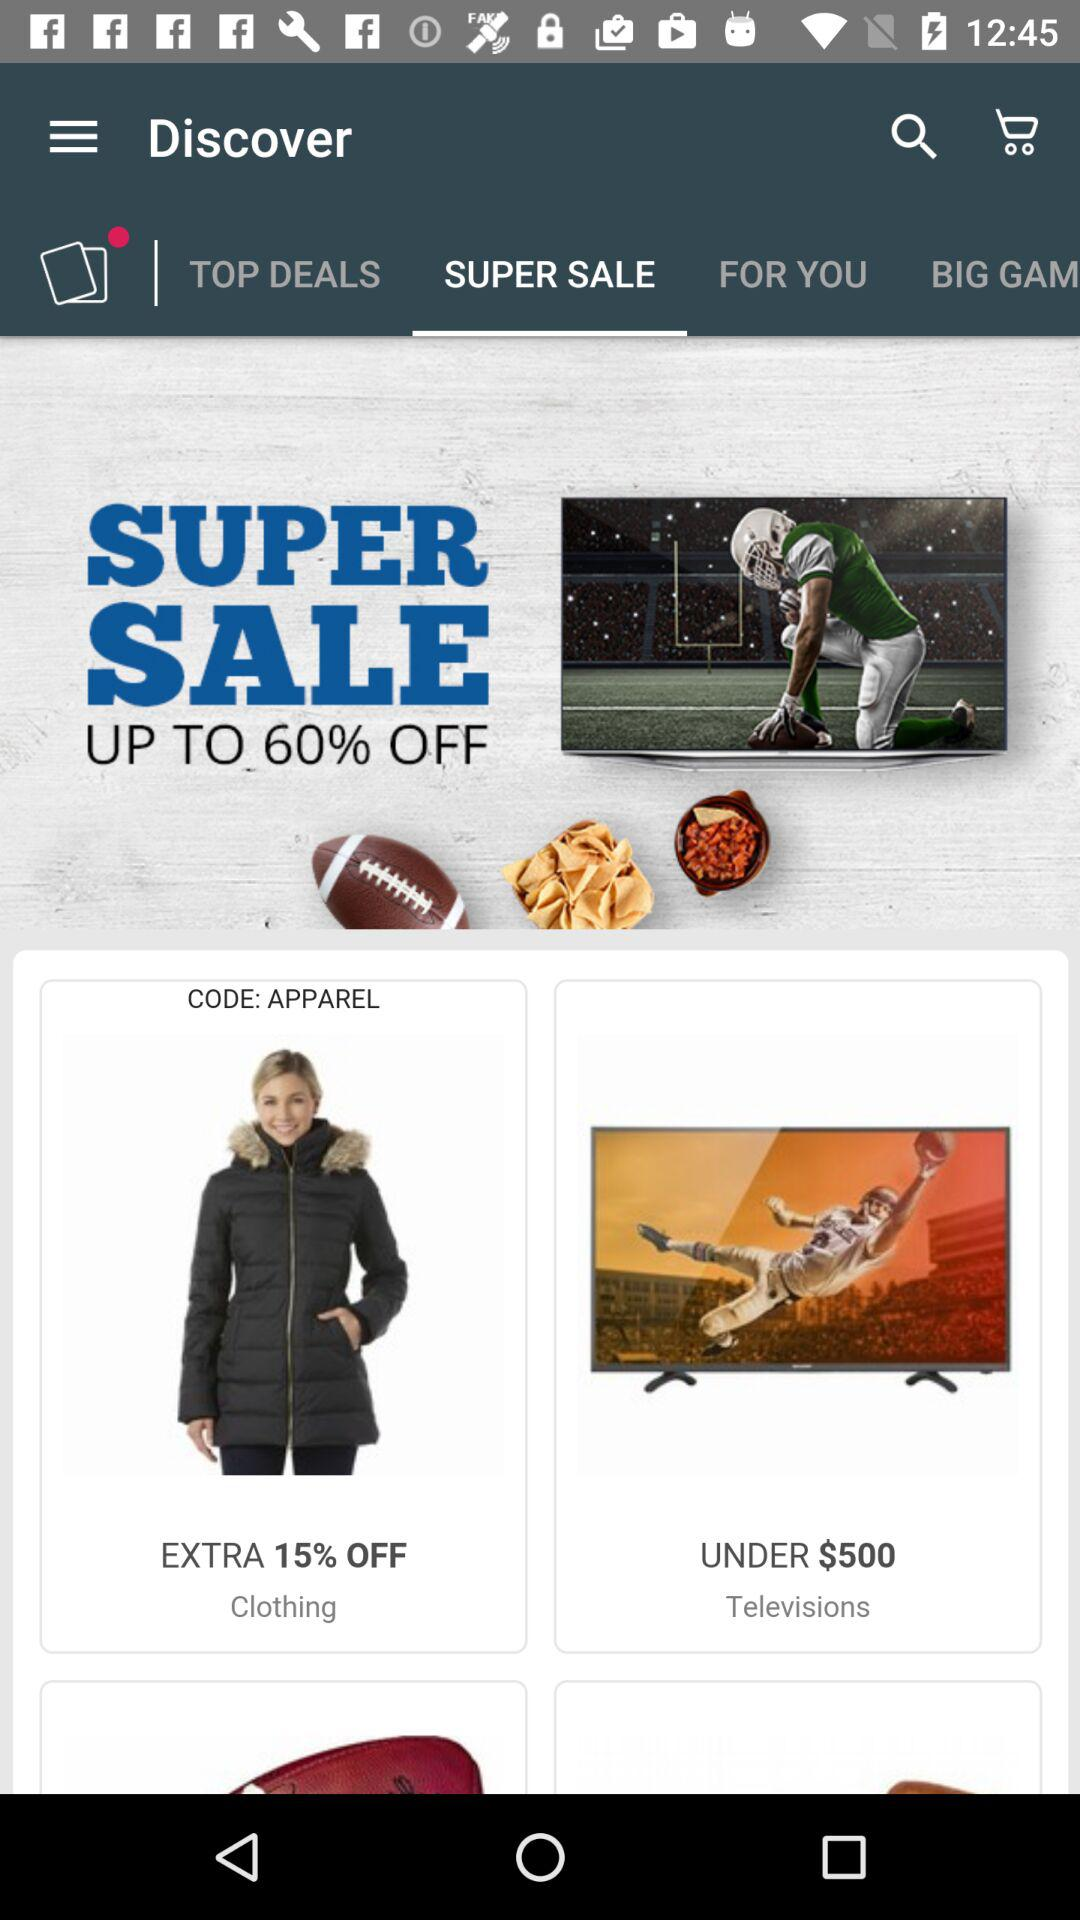How much of a discount is on clothing? The discount is an extra 15% off. 